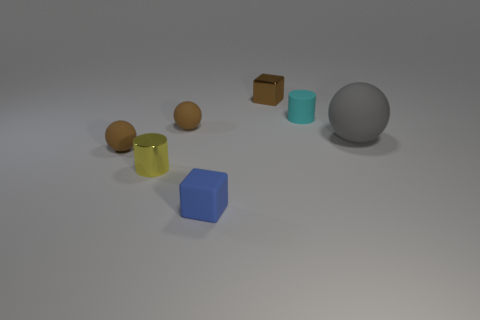Add 2 matte objects. How many objects exist? 9 Subtract all small matte spheres. How many spheres are left? 1 Subtract all cyan cylinders. How many cylinders are left? 1 Subtract all cyan rubber cylinders. Subtract all brown shiny things. How many objects are left? 5 Add 5 rubber balls. How many rubber balls are left? 8 Add 1 small cyan rubber cylinders. How many small cyan rubber cylinders exist? 2 Subtract 0 cyan blocks. How many objects are left? 7 Subtract all cubes. How many objects are left? 5 Subtract 2 cubes. How many cubes are left? 0 Subtract all purple cylinders. Subtract all purple spheres. How many cylinders are left? 2 